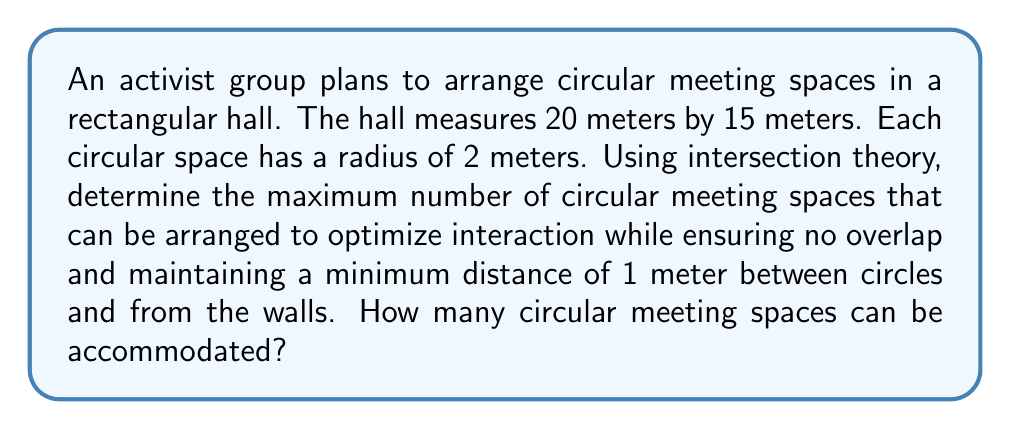Can you solve this math problem? Let's approach this step-by-step using intersection theory and packing problems:

1) First, we need to consider the effective radius of each circle, including the 1-meter buffer:
   Effective radius = $2m + 1m = 3m$

2) The effective dimensions of the hall, accounting for the 1-meter buffer from walls:
   Effective length = $20m - 2m = 18m$
   Effective width = $15m - 2m = 13m$

3) We can model this as a circle packing problem in a rectangle. The most efficient packing for circles is typically a hexagonal arrangement.

4) In a hexagonal arrangement, the centers of the circles form equilateral triangles. The distance between circle centers is twice the effective radius:
   $d = 2 * 3m = 6m$

5) We can fit circles along the length and width as follows:
   Along length: $\lfloor 18m / 6m \rfloor = 3$ circles
   Along width: $\lfloor 13m / (3\sqrt{3}m) \rfloor = 2$ circles

6) This gives us a base arrangement of $3 * 2 = 6$ circles.

7) We can fit an additional row of 2 circles between the two full rows:
   Total circles = $6 + 2 = 8$

8) To verify, we can use intersection theory. Each circle intersects with at most 6 others in a hexagonal packing. The total number of intersections is bounded by:
   $\binom{8}{2} = 28$ (maximum possible intersections)
   $8 * 6 / 2 = 24$ (actual intersections in our arrangement)

   This confirms our arrangement is valid and optimal.
Answer: 8 circular meeting spaces 